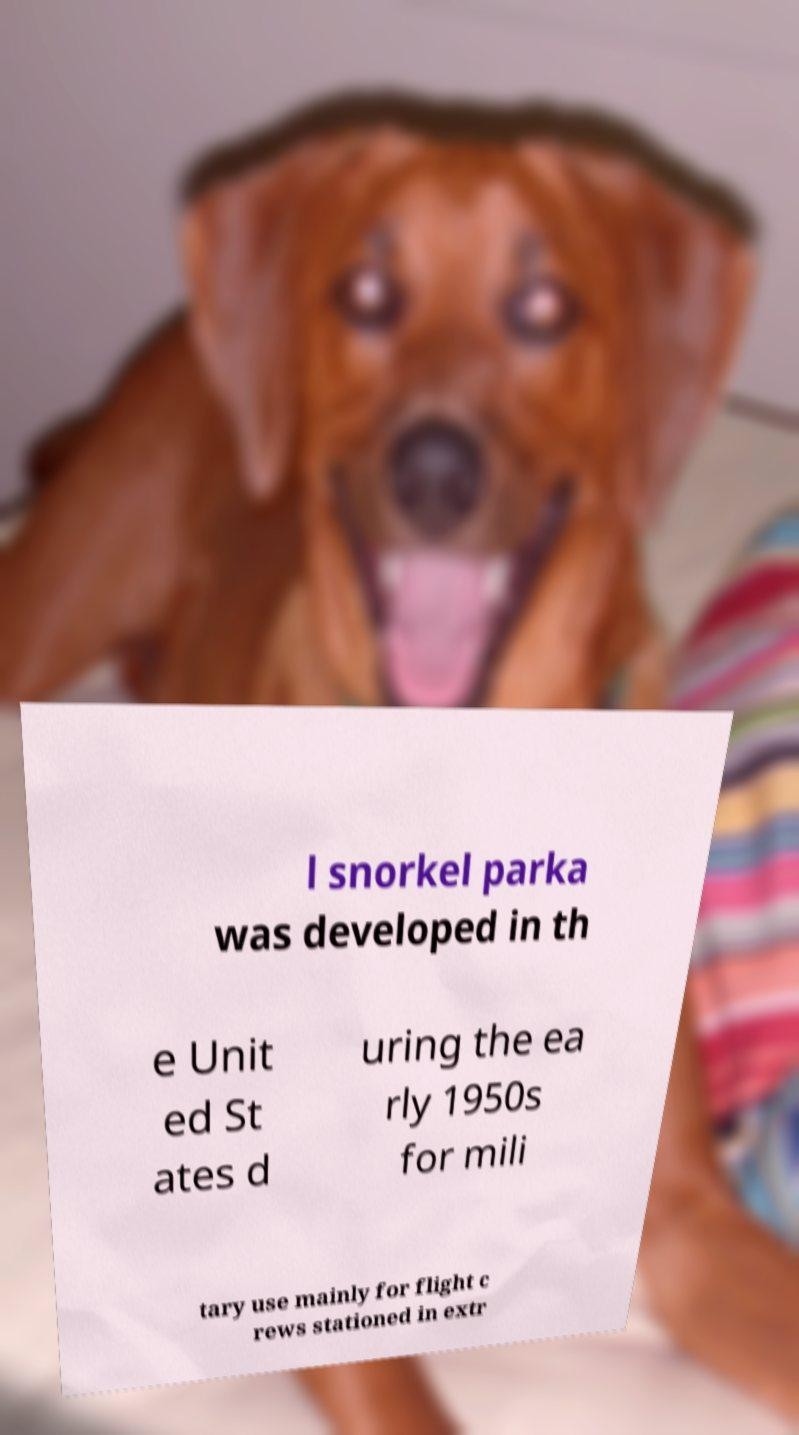What messages or text are displayed in this image? I need them in a readable, typed format. l snorkel parka was developed in th e Unit ed St ates d uring the ea rly 1950s for mili tary use mainly for flight c rews stationed in extr 